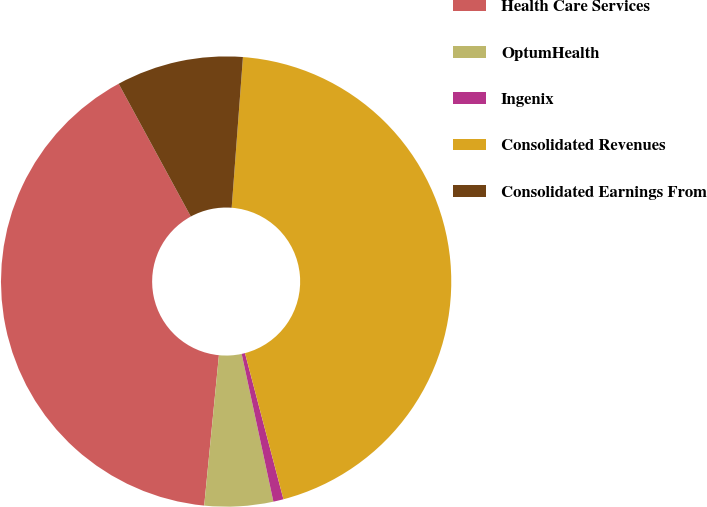Convert chart to OTSL. <chart><loc_0><loc_0><loc_500><loc_500><pie_chart><fcel>Health Care Services<fcel>OptumHealth<fcel>Ingenix<fcel>Consolidated Revenues<fcel>Consolidated Earnings From<nl><fcel>40.52%<fcel>4.92%<fcel>0.73%<fcel>44.71%<fcel>9.11%<nl></chart> 